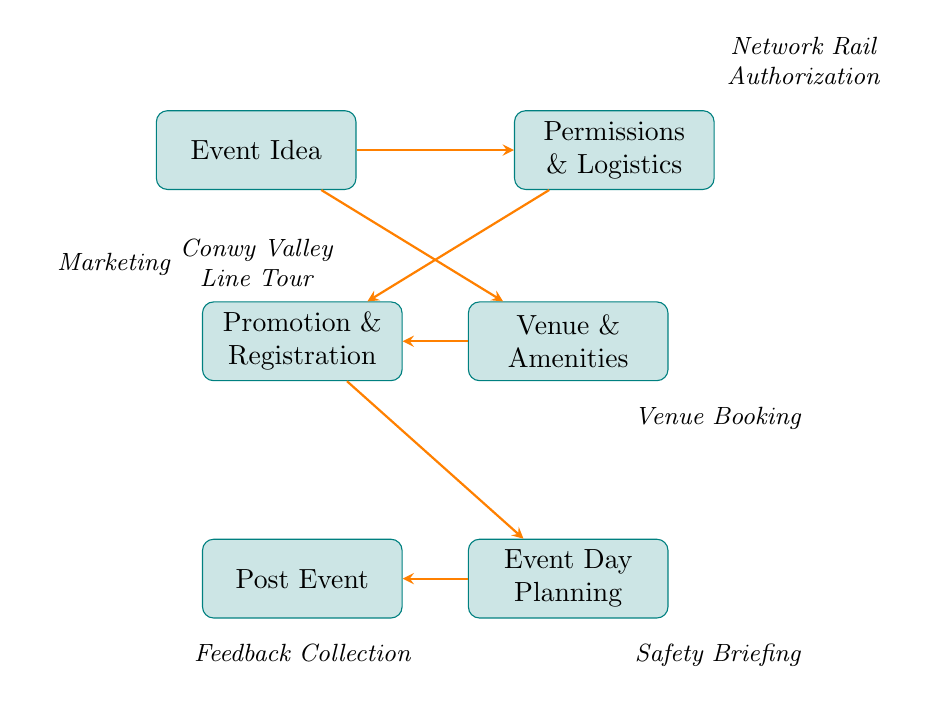What is the first step in organizing the event? The first step is to generate an event idea, which in this case is the "Conwy Valley Line Tour." This is indicated as the starting node in the diagram.
Answer: Event Idea How many nodes are there in the diagram? The diagram consists of six nodes that represent different steps in the event organization process. These nodes include Event Idea, Permissions & Logistics, Venue & Amenities, Promotion & Registration, Event Day Planning, and Post Event.
Answer: Six Which nodes must be completed before moving on to Event Day Planning? To proceed to Event Day Planning, both the Promotion & Registration and Venue & Amenities nodes must be completed. The arrows in the diagram indicate that these nodes feed into Event Day Planning, meaning they need to be addressed beforehand.
Answer: Promotion & Registration, Venue & Amenities What is necessary for securing "Local Council Permit"? The diagram does not specifically detail what is necessary for securing the "Local Council Permit," but it indicates that this step falls under "Permissions & Logistics." Therefore, the action involves securing any required permits from Conwy County Borough Council as part of this process.
Answer: Local Council Permit What comes directly after Promotion & Registration in the event organization process? After Promotion & Registration, the next step in the flow is Event Day Planning. The diagram shows a direct arrow leading from Promotion & Registration to Event Day Planning, indicating this sequential relationship.
Answer: Event Day Planning 